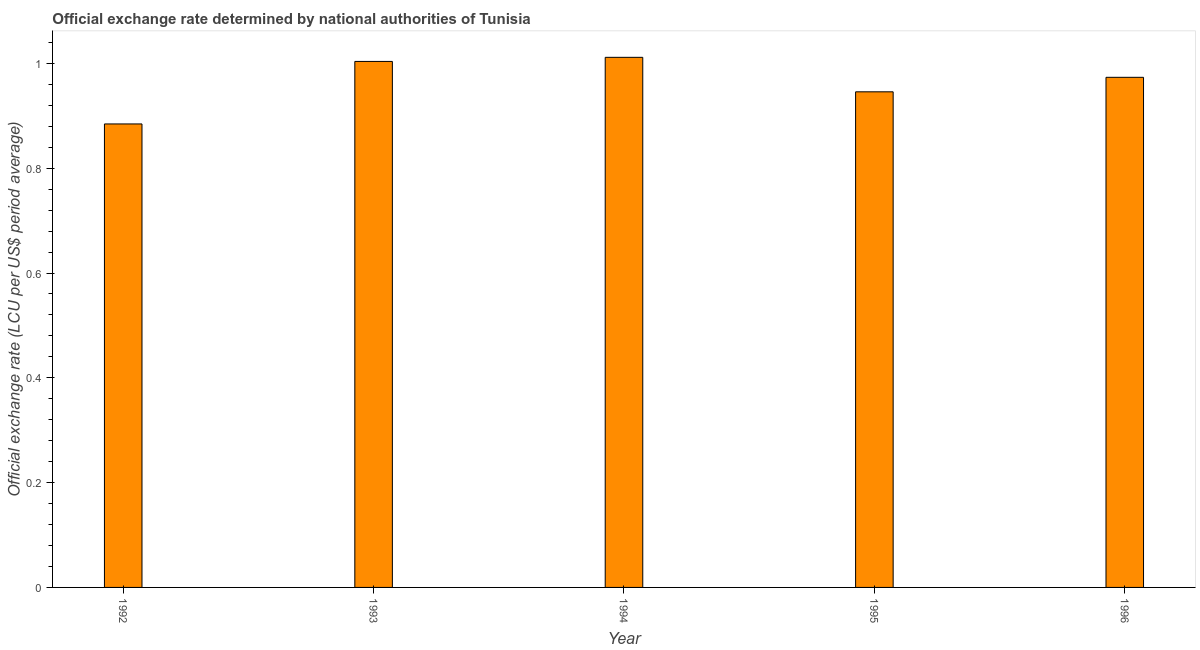What is the title of the graph?
Offer a terse response. Official exchange rate determined by national authorities of Tunisia. What is the label or title of the X-axis?
Make the answer very short. Year. What is the label or title of the Y-axis?
Give a very brief answer. Official exchange rate (LCU per US$ period average). What is the official exchange rate in 1993?
Offer a very short reply. 1. Across all years, what is the maximum official exchange rate?
Your response must be concise. 1.01. Across all years, what is the minimum official exchange rate?
Your answer should be compact. 0.88. In which year was the official exchange rate maximum?
Keep it short and to the point. 1994. In which year was the official exchange rate minimum?
Provide a short and direct response. 1992. What is the sum of the official exchange rate?
Offer a terse response. 4.82. What is the difference between the official exchange rate in 1992 and 1994?
Give a very brief answer. -0.13. What is the average official exchange rate per year?
Provide a succinct answer. 0.96. What is the median official exchange rate?
Offer a terse response. 0.97. What is the ratio of the official exchange rate in 1995 to that in 1996?
Offer a very short reply. 0.97. Is the official exchange rate in 1994 less than that in 1996?
Provide a succinct answer. No. What is the difference between the highest and the second highest official exchange rate?
Offer a very short reply. 0.01. What is the difference between the highest and the lowest official exchange rate?
Keep it short and to the point. 0.13. What is the difference between two consecutive major ticks on the Y-axis?
Offer a terse response. 0.2. What is the Official exchange rate (LCU per US$ period average) in 1992?
Offer a terse response. 0.88. What is the Official exchange rate (LCU per US$ period average) of 1993?
Your answer should be compact. 1. What is the Official exchange rate (LCU per US$ period average) of 1994?
Keep it short and to the point. 1.01. What is the Official exchange rate (LCU per US$ period average) in 1995?
Your answer should be compact. 0.95. What is the Official exchange rate (LCU per US$ period average) in 1996?
Offer a terse response. 0.97. What is the difference between the Official exchange rate (LCU per US$ period average) in 1992 and 1993?
Keep it short and to the point. -0.12. What is the difference between the Official exchange rate (LCU per US$ period average) in 1992 and 1994?
Make the answer very short. -0.13. What is the difference between the Official exchange rate (LCU per US$ period average) in 1992 and 1995?
Keep it short and to the point. -0.06. What is the difference between the Official exchange rate (LCU per US$ period average) in 1992 and 1996?
Offer a terse response. -0.09. What is the difference between the Official exchange rate (LCU per US$ period average) in 1993 and 1994?
Provide a succinct answer. -0.01. What is the difference between the Official exchange rate (LCU per US$ period average) in 1993 and 1995?
Keep it short and to the point. 0.06. What is the difference between the Official exchange rate (LCU per US$ period average) in 1993 and 1996?
Your answer should be compact. 0.03. What is the difference between the Official exchange rate (LCU per US$ period average) in 1994 and 1995?
Offer a very short reply. 0.07. What is the difference between the Official exchange rate (LCU per US$ period average) in 1994 and 1996?
Offer a very short reply. 0.04. What is the difference between the Official exchange rate (LCU per US$ period average) in 1995 and 1996?
Provide a short and direct response. -0.03. What is the ratio of the Official exchange rate (LCU per US$ period average) in 1992 to that in 1993?
Ensure brevity in your answer.  0.88. What is the ratio of the Official exchange rate (LCU per US$ period average) in 1992 to that in 1994?
Your answer should be compact. 0.87. What is the ratio of the Official exchange rate (LCU per US$ period average) in 1992 to that in 1995?
Offer a very short reply. 0.94. What is the ratio of the Official exchange rate (LCU per US$ period average) in 1992 to that in 1996?
Provide a short and direct response. 0.91. What is the ratio of the Official exchange rate (LCU per US$ period average) in 1993 to that in 1995?
Your response must be concise. 1.06. What is the ratio of the Official exchange rate (LCU per US$ period average) in 1993 to that in 1996?
Offer a very short reply. 1.03. What is the ratio of the Official exchange rate (LCU per US$ period average) in 1994 to that in 1995?
Provide a succinct answer. 1.07. What is the ratio of the Official exchange rate (LCU per US$ period average) in 1994 to that in 1996?
Keep it short and to the point. 1.04. What is the ratio of the Official exchange rate (LCU per US$ period average) in 1995 to that in 1996?
Your answer should be compact. 0.97. 